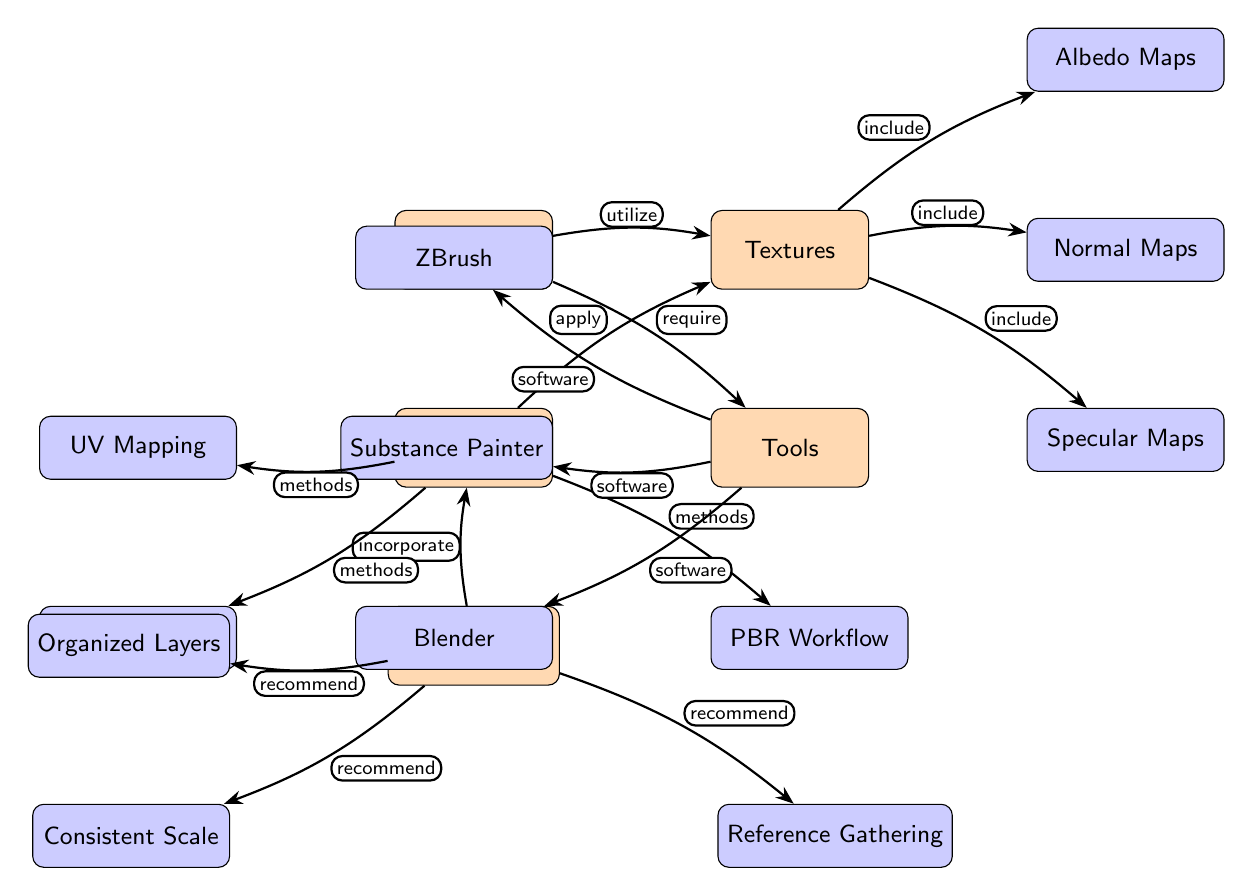What are the main categories highlighted in the diagram? The diagram prominently features five main categories: Materials, Textures, Techniques, Tools, and Best Practices. Each is represented as a main node in the diagram.
Answer: Materials, Textures, Techniques, Tools, Best Practices How many sub-nodes are connected to Textures? Textures has three sub-nodes connected to it: Albedo Maps, Normal Maps, and Specular Maps, making a total of three.
Answer: 3 What relationship does Materials have with Textures? The relationship between Materials and Textures is indicated by the edge labeled "utilize," showing that materials are used to create textures.
Answer: utilize What methods are associated with Techniques? Techniques includes three methods: UV Mapping, Baking, and PBR Workflow, which are shown as sub-nodes.
Answer: UV Mapping, Baking, PBR Workflow Which tools are recommended for 3D sculpting? The Tools node includes three recommended software tools: ZBrush, Substance Painter, and Blender.
Answer: ZBrush, Substance Painter, Blender What is the connection between Best Practices and Techniques? The edge connecting Best Practices to Techniques is labeled "incorporate," indicating that best practices should be integrated or adopted in the techniques applied in 3D sculpting.
Answer: incorporate What specific types of maps are included under Textures? Under Textures, the specific types of maps included are Albedo Maps, Normal Maps, and Specular Maps, allowing for a detailed texturing process.
Answer: Albedo Maps, Normal Maps, Specular Maps Which sub-node is located directly below Techniques? Directly below Techniques is the Tools node, which is a main category highlighting the software used.
Answer: Tools What recommendation is associated with layers under Best Practices? The sub-node associated with layers under Best Practices is "Organized Layers," which emphasizes the importance of maintaining order in the layering system.
Answer: Organized Layers 